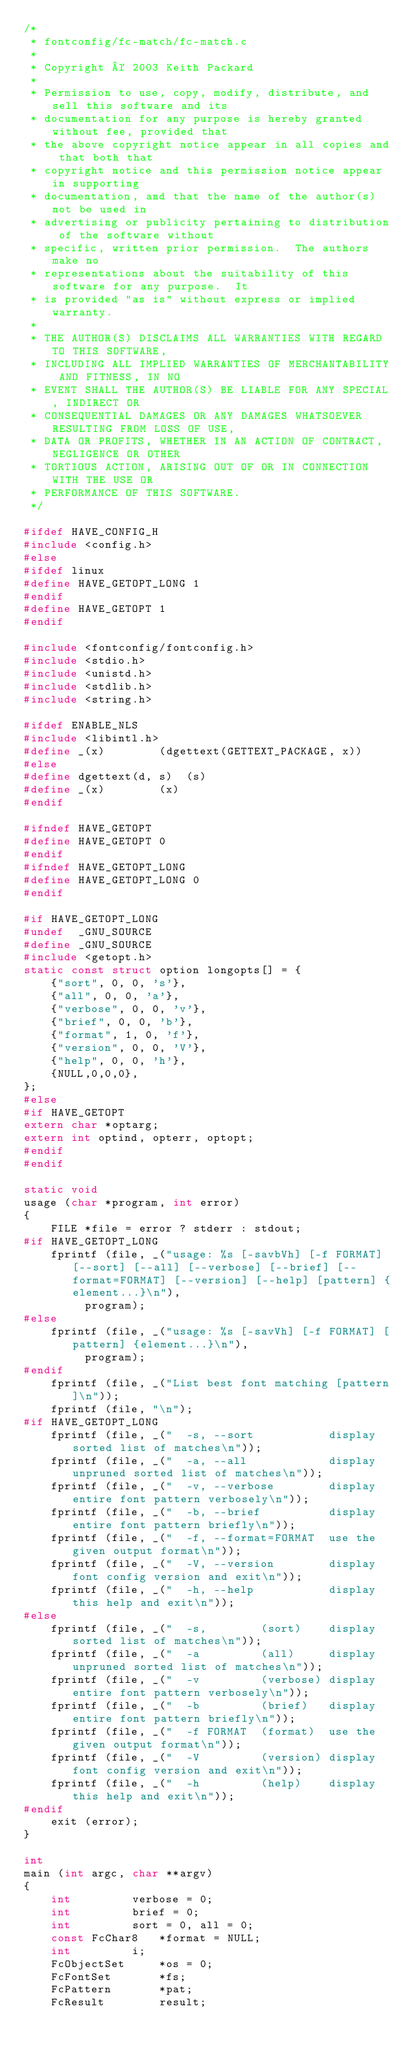<code> <loc_0><loc_0><loc_500><loc_500><_C_>/*
 * fontconfig/fc-match/fc-match.c
 *
 * Copyright © 2003 Keith Packard
 *
 * Permission to use, copy, modify, distribute, and sell this software and its
 * documentation for any purpose is hereby granted without fee, provided that
 * the above copyright notice appear in all copies and that both that
 * copyright notice and this permission notice appear in supporting
 * documentation, and that the name of the author(s) not be used in
 * advertising or publicity pertaining to distribution of the software without
 * specific, written prior permission.  The authors make no
 * representations about the suitability of this software for any purpose.  It
 * is provided "as is" without express or implied warranty.
 *
 * THE AUTHOR(S) DISCLAIMS ALL WARRANTIES WITH REGARD TO THIS SOFTWARE,
 * INCLUDING ALL IMPLIED WARRANTIES OF MERCHANTABILITY AND FITNESS, IN NO
 * EVENT SHALL THE AUTHOR(S) BE LIABLE FOR ANY SPECIAL, INDIRECT OR
 * CONSEQUENTIAL DAMAGES OR ANY DAMAGES WHATSOEVER RESULTING FROM LOSS OF USE,
 * DATA OR PROFITS, WHETHER IN AN ACTION OF CONTRACT, NEGLIGENCE OR OTHER
 * TORTIOUS ACTION, ARISING OUT OF OR IN CONNECTION WITH THE USE OR
 * PERFORMANCE OF THIS SOFTWARE.
 */

#ifdef HAVE_CONFIG_H
#include <config.h>
#else
#ifdef linux
#define HAVE_GETOPT_LONG 1
#endif
#define HAVE_GETOPT 1
#endif

#include <fontconfig/fontconfig.h>
#include <stdio.h>
#include <unistd.h>
#include <stdlib.h>
#include <string.h>

#ifdef ENABLE_NLS
#include <libintl.h>
#define _(x)		(dgettext(GETTEXT_PACKAGE, x))
#else
#define dgettext(d, s)	(s)
#define _(x)		(x)
#endif

#ifndef HAVE_GETOPT
#define HAVE_GETOPT 0
#endif
#ifndef HAVE_GETOPT_LONG
#define HAVE_GETOPT_LONG 0
#endif

#if HAVE_GETOPT_LONG
#undef  _GNU_SOURCE
#define _GNU_SOURCE
#include <getopt.h>
static const struct option longopts[] = {
    {"sort", 0, 0, 's'},
    {"all", 0, 0, 'a'},
    {"verbose", 0, 0, 'v'},
    {"brief", 0, 0, 'b'},
    {"format", 1, 0, 'f'},
    {"version", 0, 0, 'V'},
    {"help", 0, 0, 'h'},
    {NULL,0,0,0},
};
#else
#if HAVE_GETOPT
extern char *optarg;
extern int optind, opterr, optopt;
#endif
#endif

static void
usage (char *program, int error)
{
    FILE *file = error ? stderr : stdout;
#if HAVE_GETOPT_LONG
    fprintf (file, _("usage: %s [-savbVh] [-f FORMAT] [--sort] [--all] [--verbose] [--brief] [--format=FORMAT] [--version] [--help] [pattern] {element...}\n"),
	     program);
#else
    fprintf (file, _("usage: %s [-savVh] [-f FORMAT] [pattern] {element...}\n"),
	     program);
#endif
    fprintf (file, _("List best font matching [pattern]\n"));
    fprintf (file, "\n");
#if HAVE_GETOPT_LONG
    fprintf (file, _("  -s, --sort           display sorted list of matches\n"));
    fprintf (file, _("  -a, --all            display unpruned sorted list of matches\n"));
    fprintf (file, _("  -v, --verbose        display entire font pattern verbosely\n"));
    fprintf (file, _("  -b, --brief          display entire font pattern briefly\n"));
    fprintf (file, _("  -f, --format=FORMAT  use the given output format\n"));
    fprintf (file, _("  -V, --version        display font config version and exit\n"));
    fprintf (file, _("  -h, --help           display this help and exit\n"));
#else
    fprintf (file, _("  -s,        (sort)    display sorted list of matches\n"));
    fprintf (file, _("  -a         (all)     display unpruned sorted list of matches\n"));
    fprintf (file, _("  -v         (verbose) display entire font pattern verbosely\n"));
    fprintf (file, _("  -b         (brief)   display entire font pattern briefly\n"));
    fprintf (file, _("  -f FORMAT  (format)  use the given output format\n"));
    fprintf (file, _("  -V         (version) display font config version and exit\n"));
    fprintf (file, _("  -h         (help)    display this help and exit\n"));
#endif
    exit (error);
}

int
main (int argc, char **argv)
{
    int			verbose = 0;
    int			brief = 0;
    int			sort = 0, all = 0;
    const FcChar8	*format = NULL;
    int			i;
    FcObjectSet		*os = 0;
    FcFontSet		*fs;
    FcPattern		*pat;
    FcResult		result;</code> 